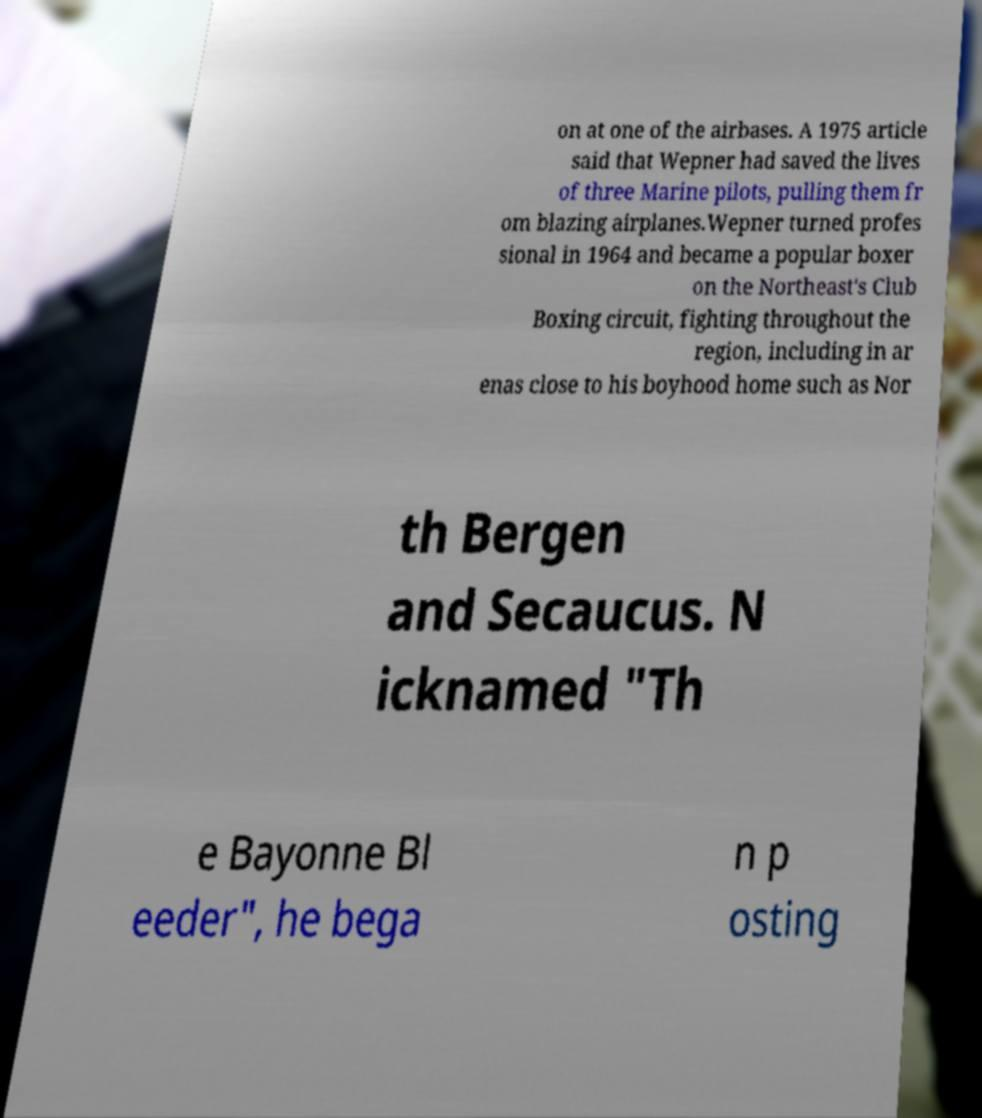Please identify and transcribe the text found in this image. on at one of the airbases. A 1975 article said that Wepner had saved the lives of three Marine pilots, pulling them fr om blazing airplanes.Wepner turned profes sional in 1964 and became a popular boxer on the Northeast's Club Boxing circuit, fighting throughout the region, including in ar enas close to his boyhood home such as Nor th Bergen and Secaucus. N icknamed "Th e Bayonne Bl eeder", he bega n p osting 